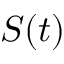<formula> <loc_0><loc_0><loc_500><loc_500>S ( t )</formula> 